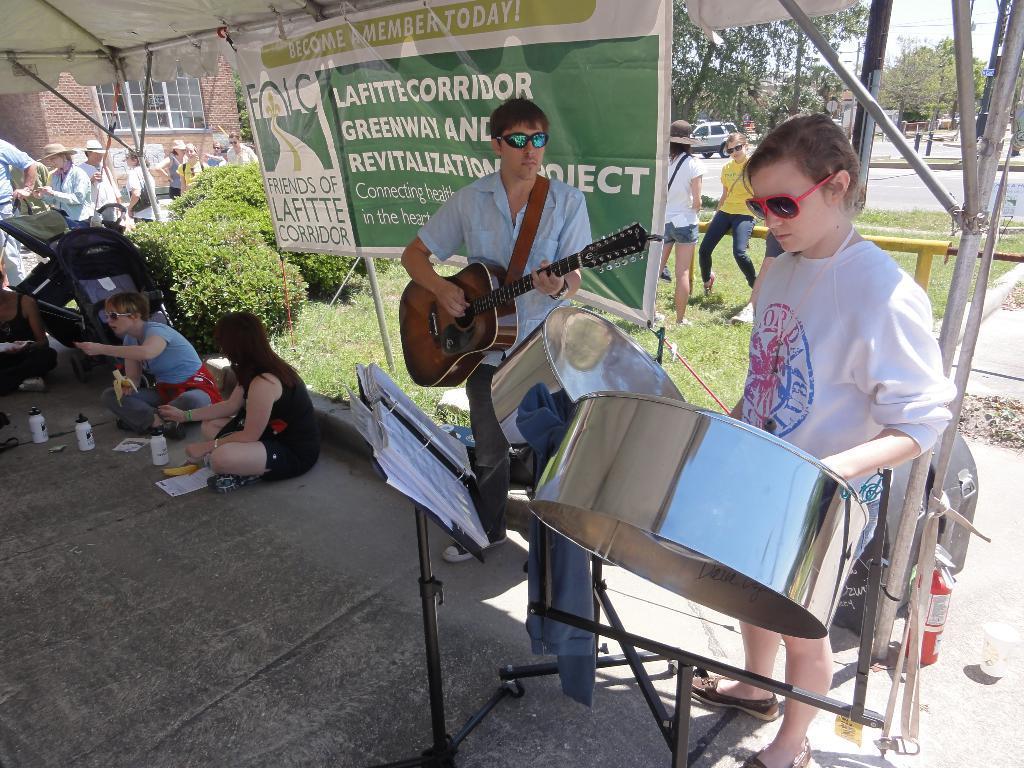Please provide a concise description of this image. This image is clicked outside. There is a Banner in the middle. There are so many people in this image, one of them is playing guitar and the other one is playing drums. There are shrubs and trees in this image. There is a building on the left side. 